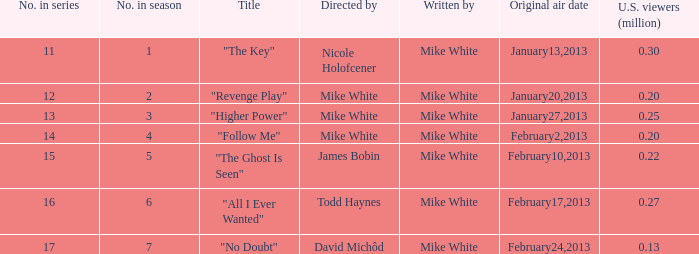In the series, how many episodes were titled "the key"? 1.0. 